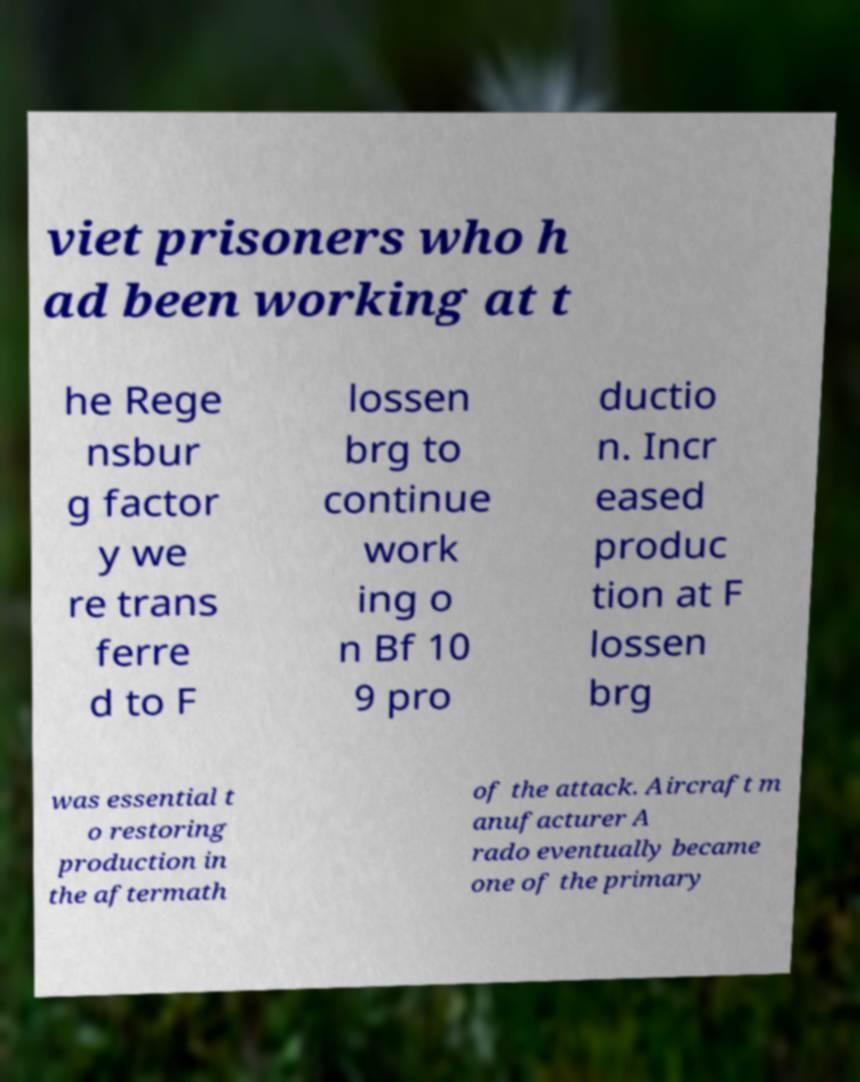For documentation purposes, I need the text within this image transcribed. Could you provide that? viet prisoners who h ad been working at t he Rege nsbur g factor y we re trans ferre d to F lossen brg to continue work ing o n Bf 10 9 pro ductio n. Incr eased produc tion at F lossen brg was essential t o restoring production in the aftermath of the attack. Aircraft m anufacturer A rado eventually became one of the primary 